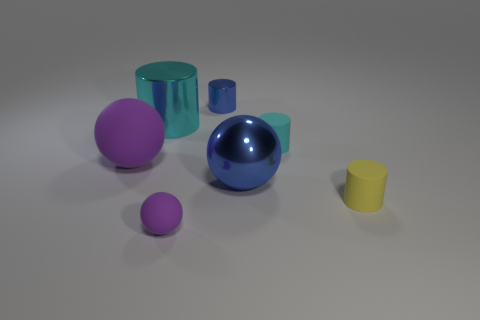What size is the thing that is the same color as the tiny shiny cylinder?
Keep it short and to the point. Large. Are there any matte things that have the same color as the tiny rubber sphere?
Make the answer very short. Yes. The metallic ball that is the same size as the cyan metal cylinder is what color?
Keep it short and to the point. Blue. Are there any shiny objects that have the same shape as the cyan matte thing?
Provide a succinct answer. Yes. There is a tiny shiny thing that is the same color as the metal ball; what shape is it?
Ensure brevity in your answer.  Cylinder. There is a small cyan rubber thing that is to the left of the yellow matte thing that is to the right of the big cyan cylinder; is there a small yellow rubber object that is in front of it?
Provide a short and direct response. Yes. What is the shape of the cyan thing that is the same size as the yellow object?
Provide a succinct answer. Cylinder. There is a large matte object that is the same shape as the big blue metal object; what color is it?
Offer a terse response. Purple. What number of things are cyan cylinders or small purple balls?
Offer a terse response. 3. There is a cyan object on the right side of the large shiny cylinder; is it the same shape as the metallic thing that is to the left of the small blue shiny cylinder?
Keep it short and to the point. Yes. 